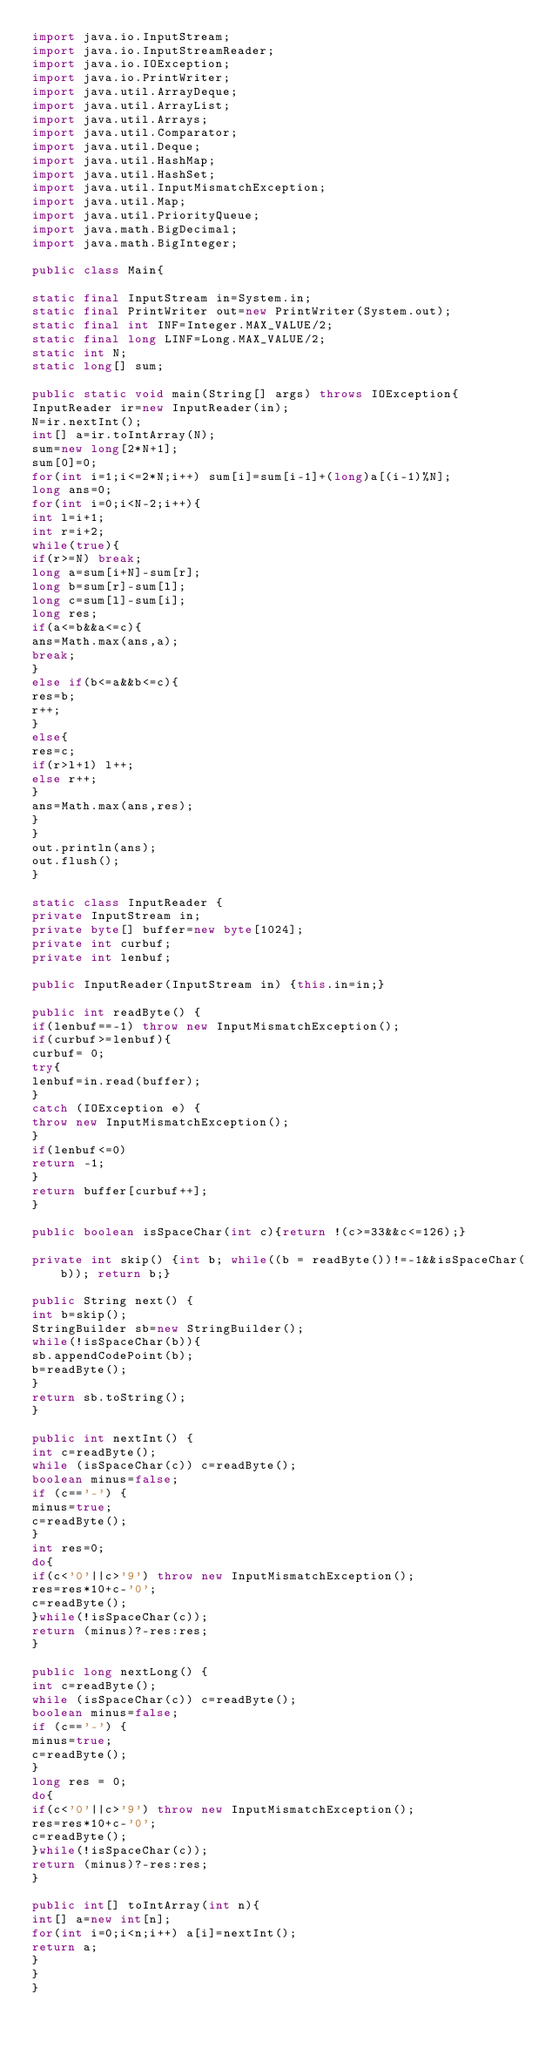<code> <loc_0><loc_0><loc_500><loc_500><_Java_>import java.io.InputStream;
import java.io.InputStreamReader;
import java.io.IOException;
import java.io.PrintWriter;
import java.util.ArrayDeque;
import java.util.ArrayList;
import java.util.Arrays;
import java.util.Comparator;
import java.util.Deque;
import java.util.HashMap;
import java.util.HashSet;
import java.util.InputMismatchException;
import java.util.Map;
import java.util.PriorityQueue;
import java.math.BigDecimal;
import java.math.BigInteger;
    
public class Main{

static final InputStream in=System.in;
static final PrintWriter out=new PrintWriter(System.out);
static final int INF=Integer.MAX_VALUE/2;
static final long LINF=Long.MAX_VALUE/2;
static int N;
static long[] sum;

public static void main(String[] args) throws IOException{
InputReader ir=new InputReader(in);
N=ir.nextInt();
int[] a=ir.toIntArray(N);
sum=new long[2*N+1];
sum[0]=0;
for(int i=1;i<=2*N;i++) sum[i]=sum[i-1]+(long)a[(i-1)%N];
long ans=0;
for(int i=0;i<N-2;i++){
int l=i+1;
int r=i+2;
while(true){
if(r>=N) break;
long a=sum[i+N]-sum[r];
long b=sum[r]-sum[l];
long c=sum[l]-sum[i];
long res;
if(a<=b&&a<=c){
ans=Math.max(ans,a);
break;
}
else if(b<=a&&b<=c){
res=b;
r++;
}
else{
res=c;
if(r>l+1) l++;
else r++;
}
ans=Math.max(ans,res);
}
}
out.println(ans);
out.flush();
}

static class InputReader {
private InputStream in;
private byte[] buffer=new byte[1024];
private int curbuf;
private int lenbuf;

public InputReader(InputStream in) {this.in=in;}
  
public int readByte() {
if(lenbuf==-1) throw new InputMismatchException();
if(curbuf>=lenbuf){
curbuf= 0;
try{
lenbuf=in.read(buffer);
}
catch (IOException e) {
throw new InputMismatchException();
}
if(lenbuf<=0)
return -1;
}
return buffer[curbuf++];
}

public boolean isSpaceChar(int c){return !(c>=33&&c<=126);}

private int skip() {int b; while((b = readByte())!=-1&&isSpaceChar(b)); return b;}

public String next() {
int b=skip();
StringBuilder sb=new StringBuilder();
while(!isSpaceChar(b)){
sb.appendCodePoint(b);
b=readByte();
}
return sb.toString();
}
 
public int nextInt() {
int c=readByte();
while (isSpaceChar(c)) c=readByte();
boolean minus=false;
if (c=='-') {
minus=true;
c=readByte();
}
int res=0;
do{
if(c<'0'||c>'9') throw new InputMismatchException();
res=res*10+c-'0';
c=readByte();
}while(!isSpaceChar(c));
return (minus)?-res:res;
}

public long nextLong() {
int c=readByte();
while (isSpaceChar(c)) c=readByte();
boolean minus=false;
if (c=='-') {
minus=true;
c=readByte();
}
long res = 0;
do{
if(c<'0'||c>'9') throw new InputMismatchException();
res=res*10+c-'0';
c=readByte();
}while(!isSpaceChar(c));
return (minus)?-res:res;
}

public int[] toIntArray(int n){
int[] a=new int[n];
for(int i=0;i<n;i++) a[i]=nextInt();
return a;
}
}
}</code> 